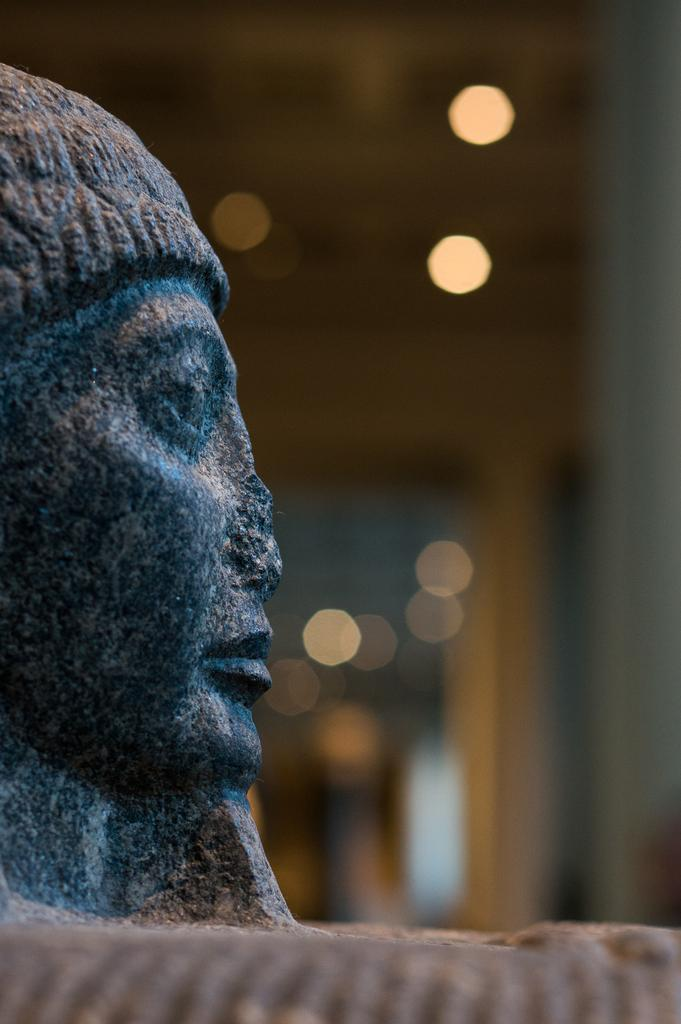What can be seen on the left side of the image? There is a sculpture on the left side of the image. Can you describe the background of the image? The background of the image is blurred. What caption is written on the mailbox in the image? There is no mailbox present in the image, so there is no caption to be read. 